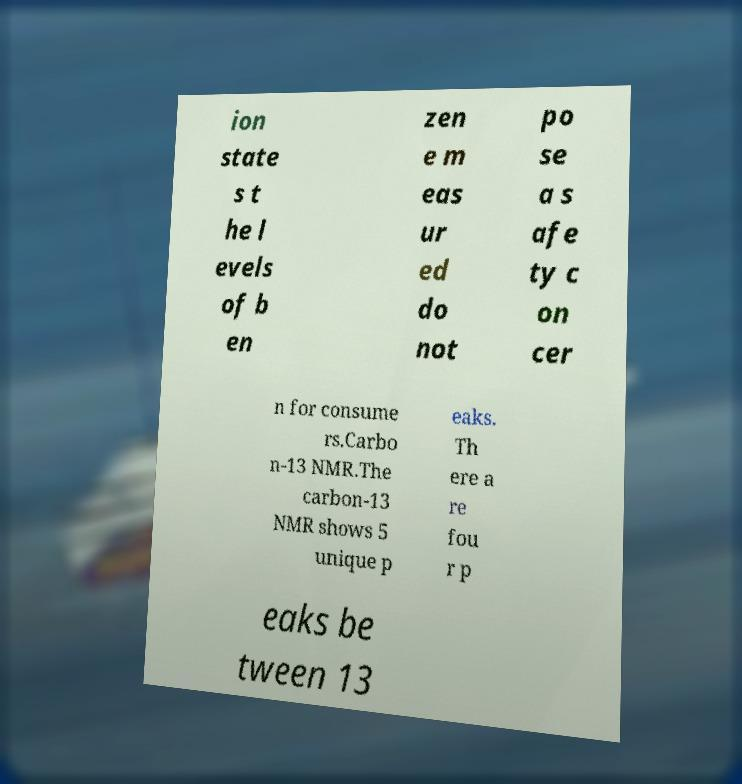Please identify and transcribe the text found in this image. ion state s t he l evels of b en zen e m eas ur ed do not po se a s afe ty c on cer n for consume rs.Carbo n-13 NMR.The carbon-13 NMR shows 5 unique p eaks. Th ere a re fou r p eaks be tween 13 